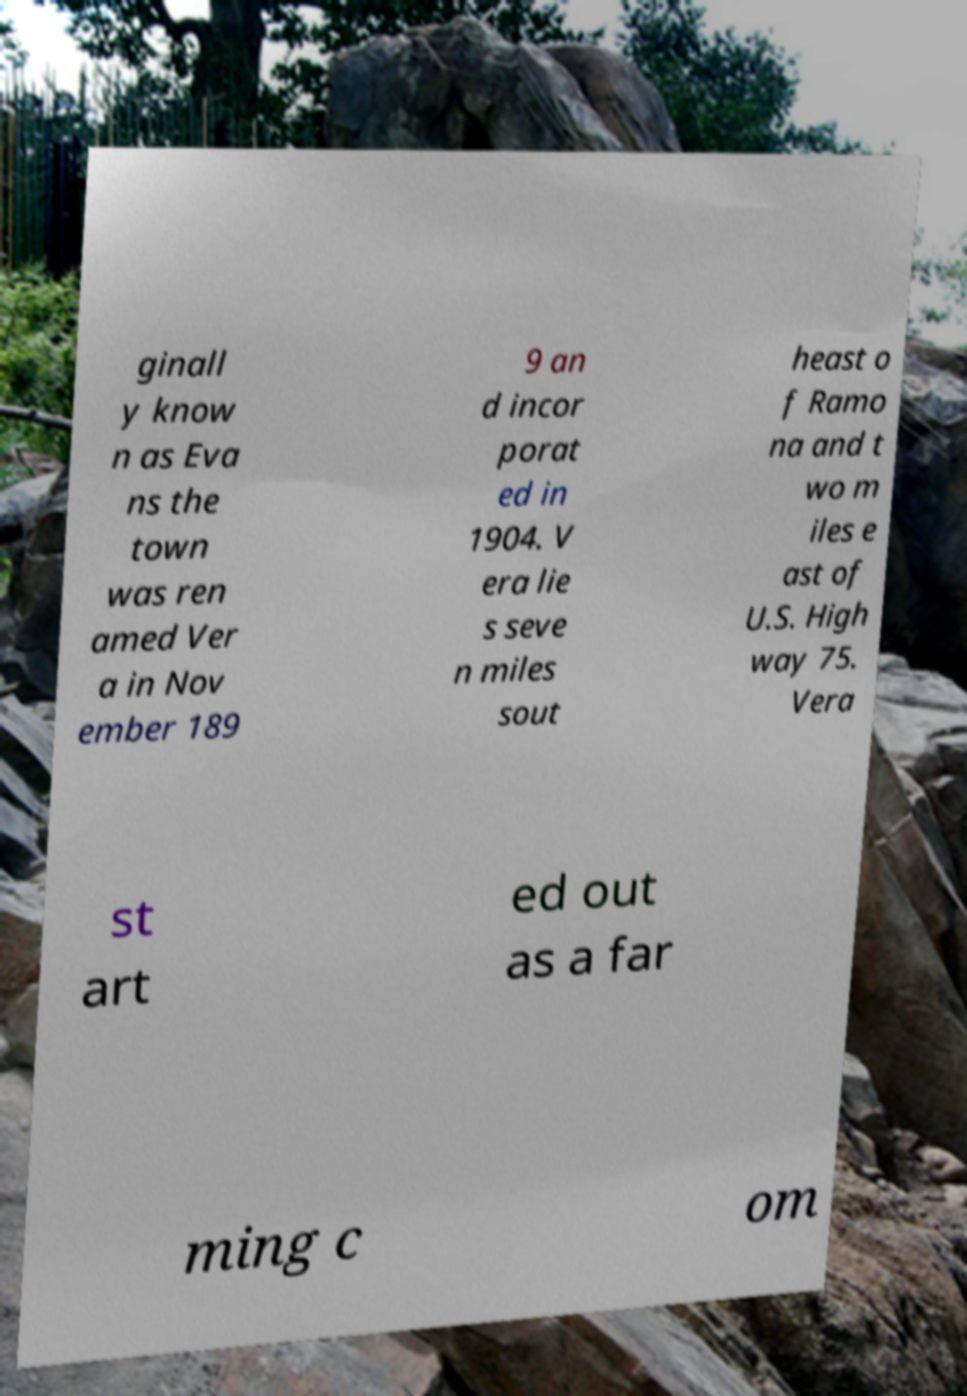Can you accurately transcribe the text from the provided image for me? ginall y know n as Eva ns the town was ren amed Ver a in Nov ember 189 9 an d incor porat ed in 1904. V era lie s seve n miles sout heast o f Ramo na and t wo m iles e ast of U.S. High way 75. Vera st art ed out as a far ming c om 